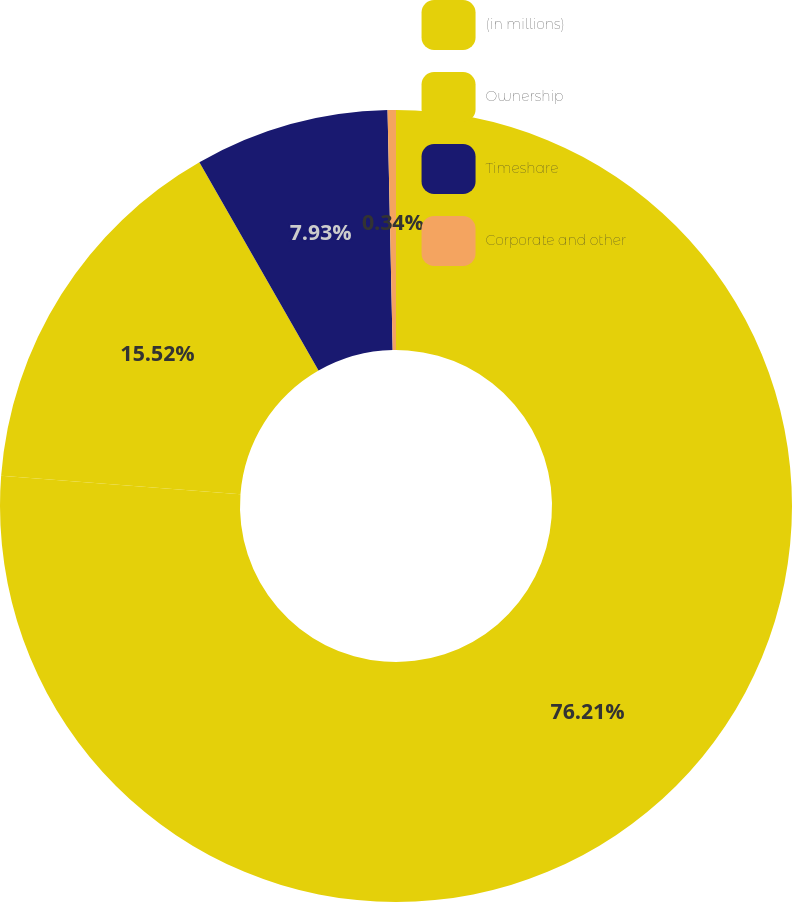<chart> <loc_0><loc_0><loc_500><loc_500><pie_chart><fcel>(in millions)<fcel>Ownership<fcel>Timeshare<fcel>Corporate and other<nl><fcel>76.22%<fcel>15.52%<fcel>7.93%<fcel>0.34%<nl></chart> 